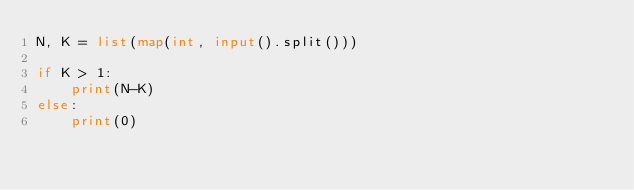Convert code to text. <code><loc_0><loc_0><loc_500><loc_500><_Python_>N, K = list(map(int, input().split()))

if K > 1:
    print(N-K)
else:
    print(0)</code> 